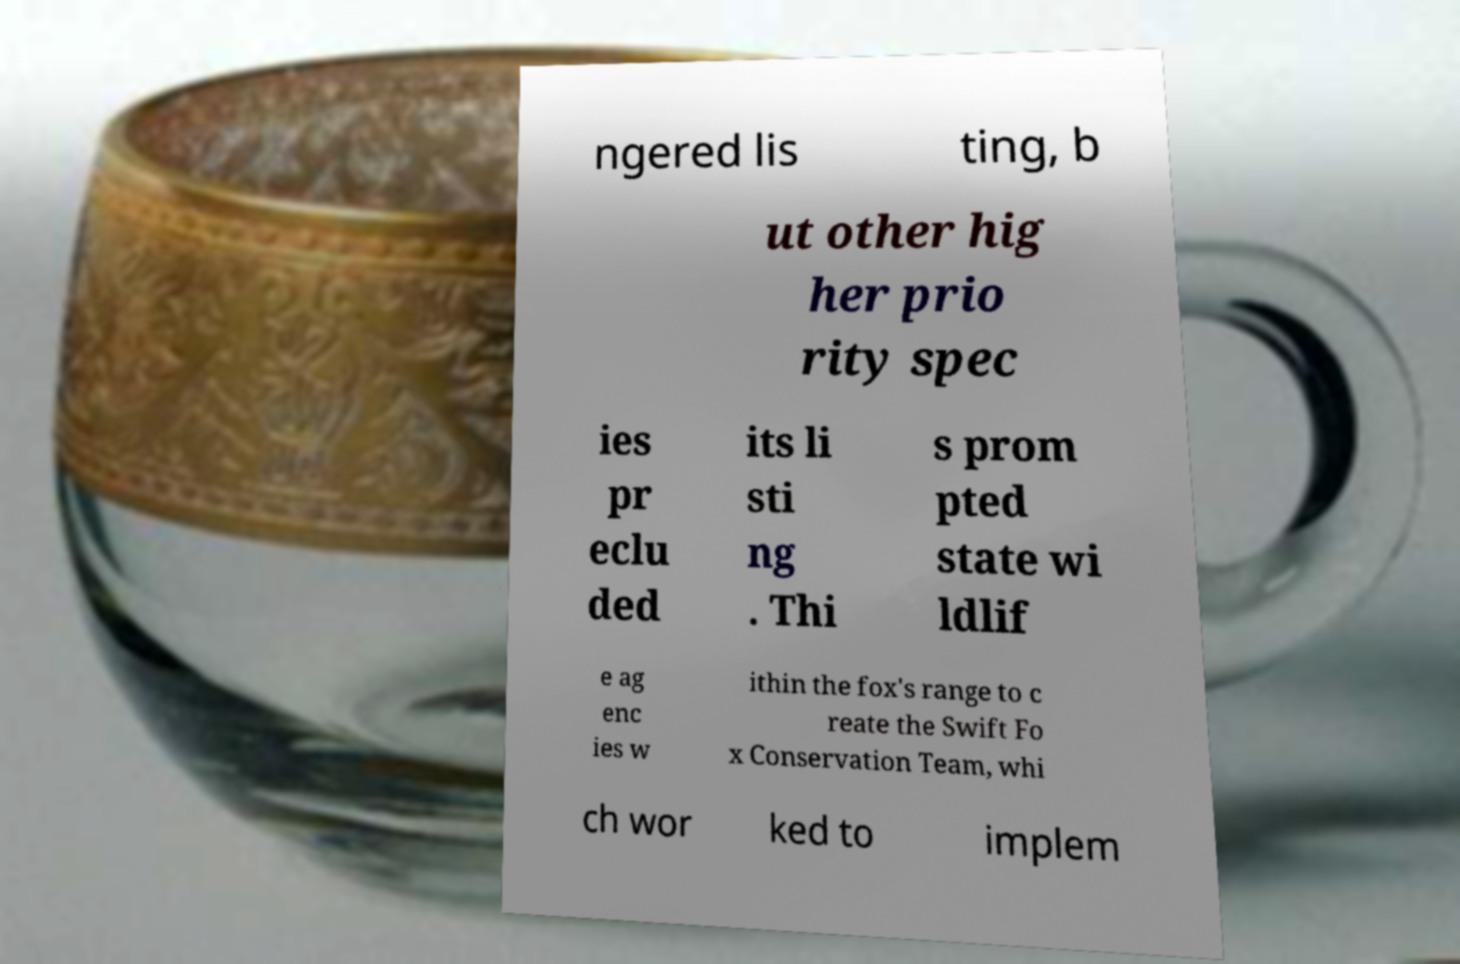What messages or text are displayed in this image? I need them in a readable, typed format. ngered lis ting, b ut other hig her prio rity spec ies pr eclu ded its li sti ng . Thi s prom pted state wi ldlif e ag enc ies w ithin the fox's range to c reate the Swift Fo x Conservation Team, whi ch wor ked to implem 